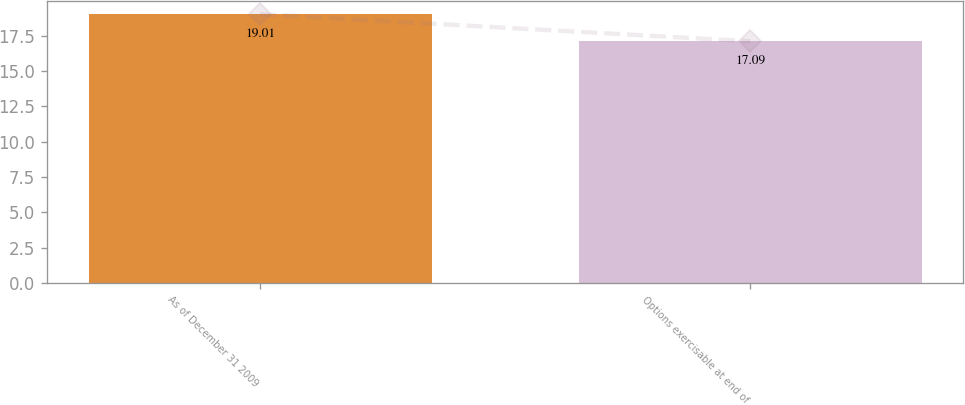Convert chart to OTSL. <chart><loc_0><loc_0><loc_500><loc_500><bar_chart><fcel>As of December 31 2009<fcel>Options exercisable at end of<nl><fcel>19.01<fcel>17.09<nl></chart> 